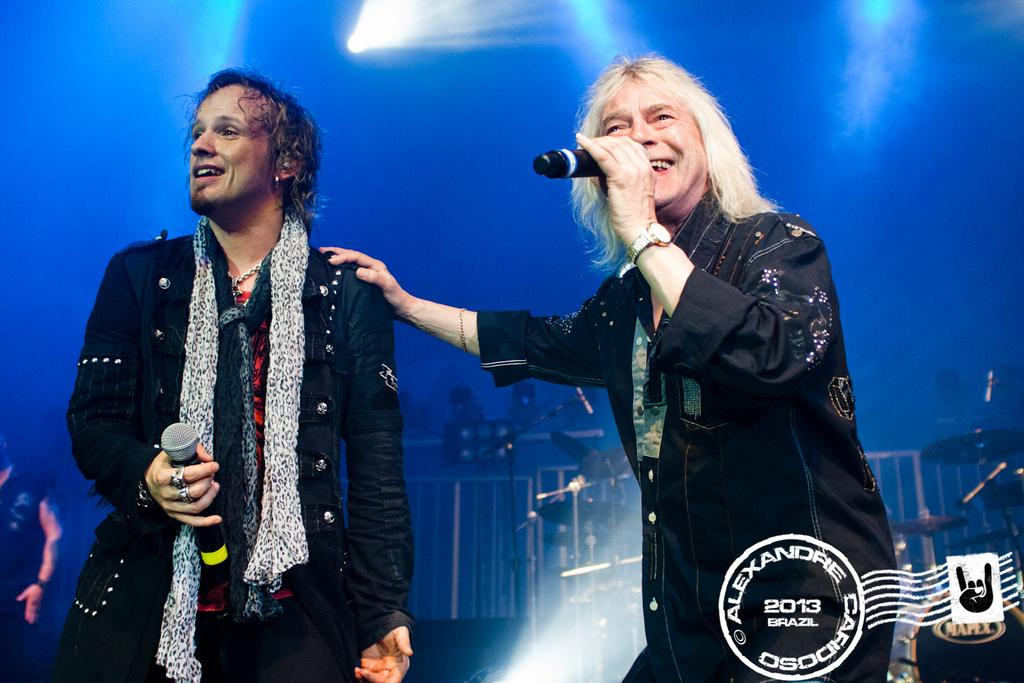Provide a one-sentence caption for the provided image. Two men adorn a postcard by Alexandre Cafidoso from 2013. 